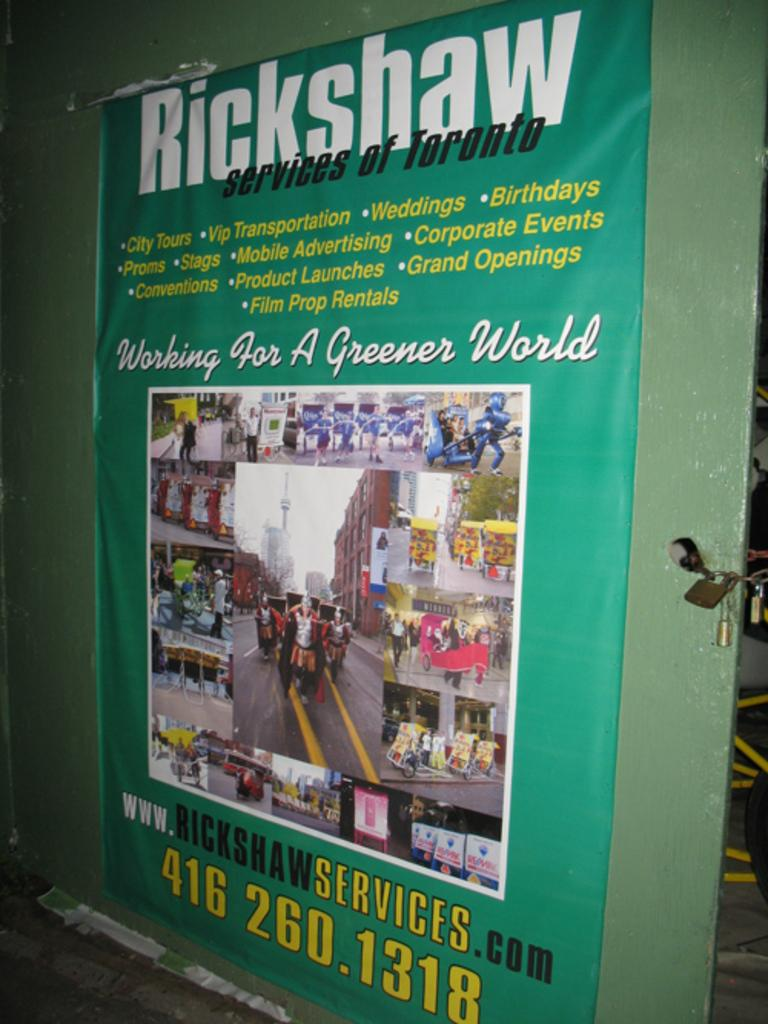<image>
Give a short and clear explanation of the subsequent image. A green poster with Rickshaw services of Toronto on it. 